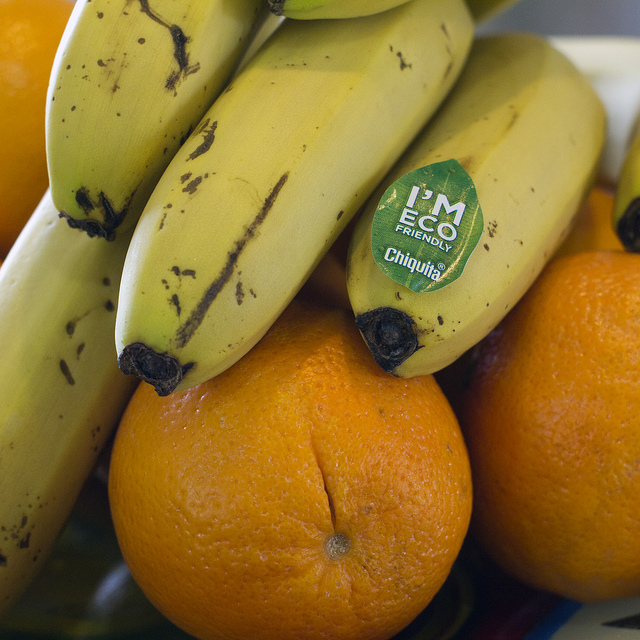<image>What is the brand on the bananas? I can't confirm the brand on the bananas, however, it might be 'chiquita'. What is the brand on the bananas? The brand on the bananas is Chiquita. 